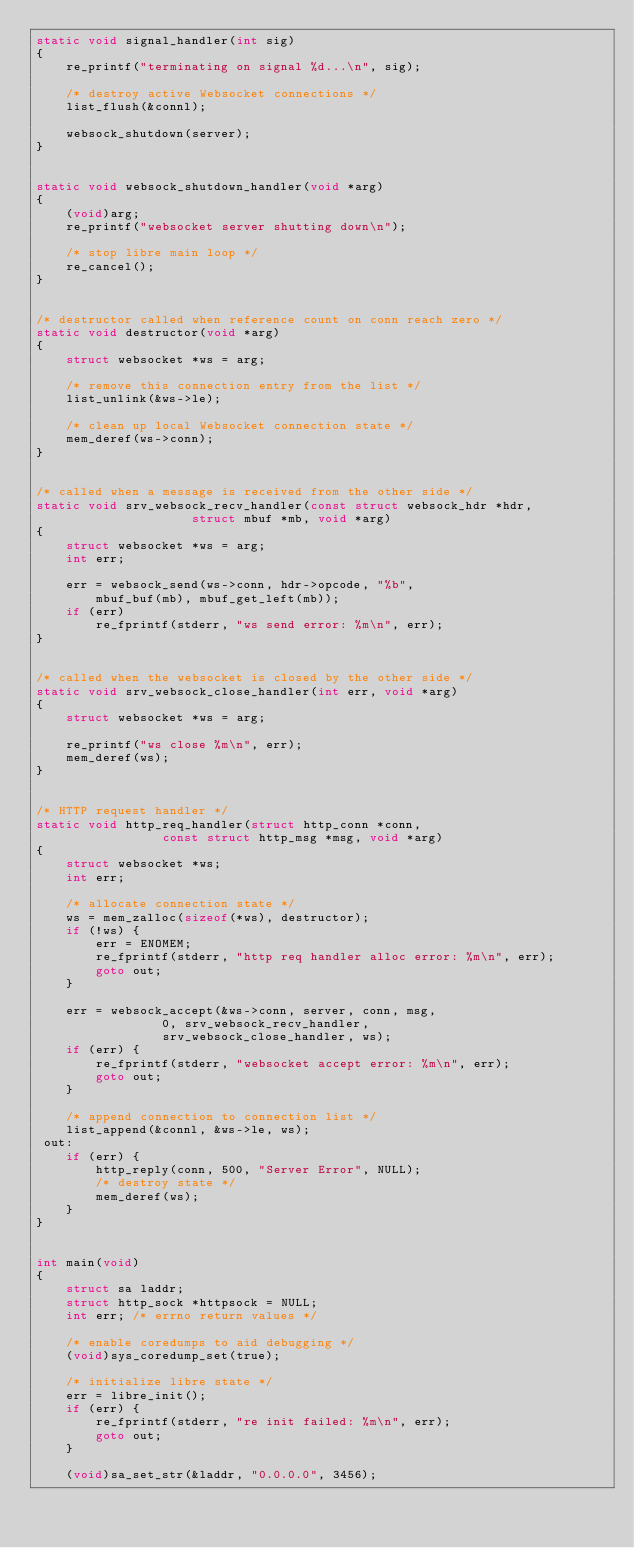<code> <loc_0><loc_0><loc_500><loc_500><_C_>static void signal_handler(int sig)
{
	re_printf("terminating on signal %d...\n", sig);

	/* destroy active Websocket connections */
	list_flush(&connl);

	websock_shutdown(server);
}


static void websock_shutdown_handler(void *arg)
{
	(void)arg;
	re_printf("websocket server shutting down\n");

	/* stop libre main loop */
	re_cancel();
}


/* destructor called when reference count on conn reach zero */
static void destructor(void *arg)
{
	struct websocket *ws = arg;

	/* remove this connection entry from the list */
	list_unlink(&ws->le);

	/* clean up local Websocket connection state */
	mem_deref(ws->conn);
}


/* called when a message is received from the other side */
static void srv_websock_recv_handler(const struct websock_hdr *hdr,
					 struct mbuf *mb, void *arg)
{
	struct websocket *ws = arg;
	int err;

	err = websock_send(ws->conn, hdr->opcode, "%b",
		mbuf_buf(mb), mbuf_get_left(mb));
	if (err)
		re_fprintf(stderr, "ws send error: %m\n", err);
}


/* called when the websocket is closed by the other side */
static void srv_websock_close_handler(int err, void *arg)
{
	struct websocket *ws = arg;

	re_printf("ws close %m\n", err);
	mem_deref(ws);
}


/* HTTP request handler */
static void http_req_handler(struct http_conn *conn,
				 const struct http_msg *msg, void *arg)
{
	struct websocket *ws;
	int err;

	/* allocate connection state */
	ws = mem_zalloc(sizeof(*ws), destructor);
	if (!ws) {
		err = ENOMEM;
		re_fprintf(stderr, "http req handler alloc error: %m\n", err);
		goto out;
	}

	err = websock_accept(&ws->conn, server, conn, msg,
				 0, srv_websock_recv_handler,
				 srv_websock_close_handler, ws);
	if (err) {
		re_fprintf(stderr, "websocket accept error: %m\n", err);
		goto out;
	}

	/* append connection to connection list */
	list_append(&connl, &ws->le, ws);
 out:
	if (err) {
		http_reply(conn, 500, "Server Error", NULL);
		/* destroy state */
		mem_deref(ws);
	}
}


int main(void)
{
	struct sa laddr;
	struct http_sock *httpsock = NULL;
	int err; /* errno return values */

	/* enable coredumps to aid debugging */
	(void)sys_coredump_set(true);

	/* initialize libre state */
	err = libre_init();
	if (err) {
		re_fprintf(stderr, "re init failed: %m\n", err);
		goto out;
	}

	(void)sa_set_str(&laddr, "0.0.0.0", 3456);
</code> 